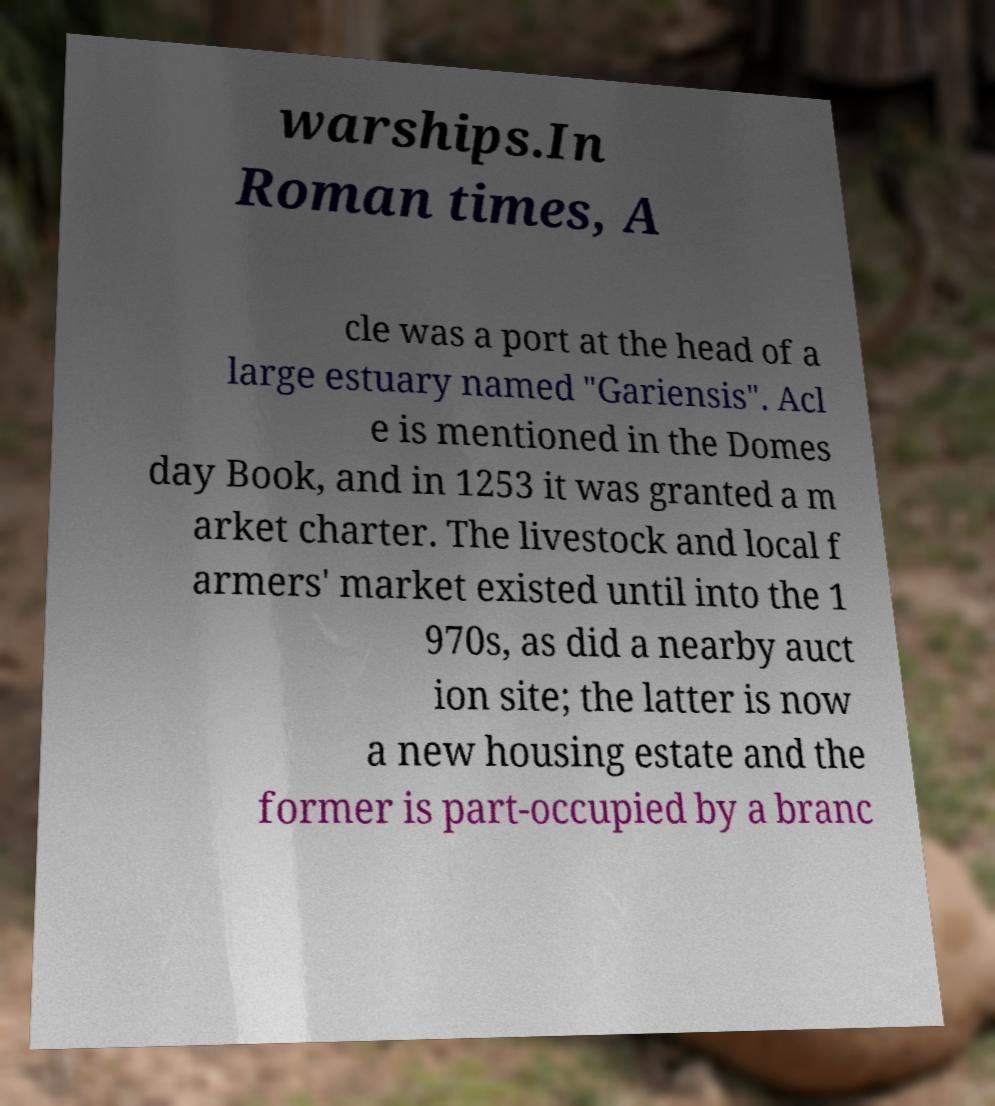There's text embedded in this image that I need extracted. Can you transcribe it verbatim? warships.In Roman times, A cle was a port at the head of a large estuary named "Gariensis". Acl e is mentioned in the Domes day Book, and in 1253 it was granted a m arket charter. The livestock and local f armers' market existed until into the 1 970s, as did a nearby auct ion site; the latter is now a new housing estate and the former is part-occupied by a branc 